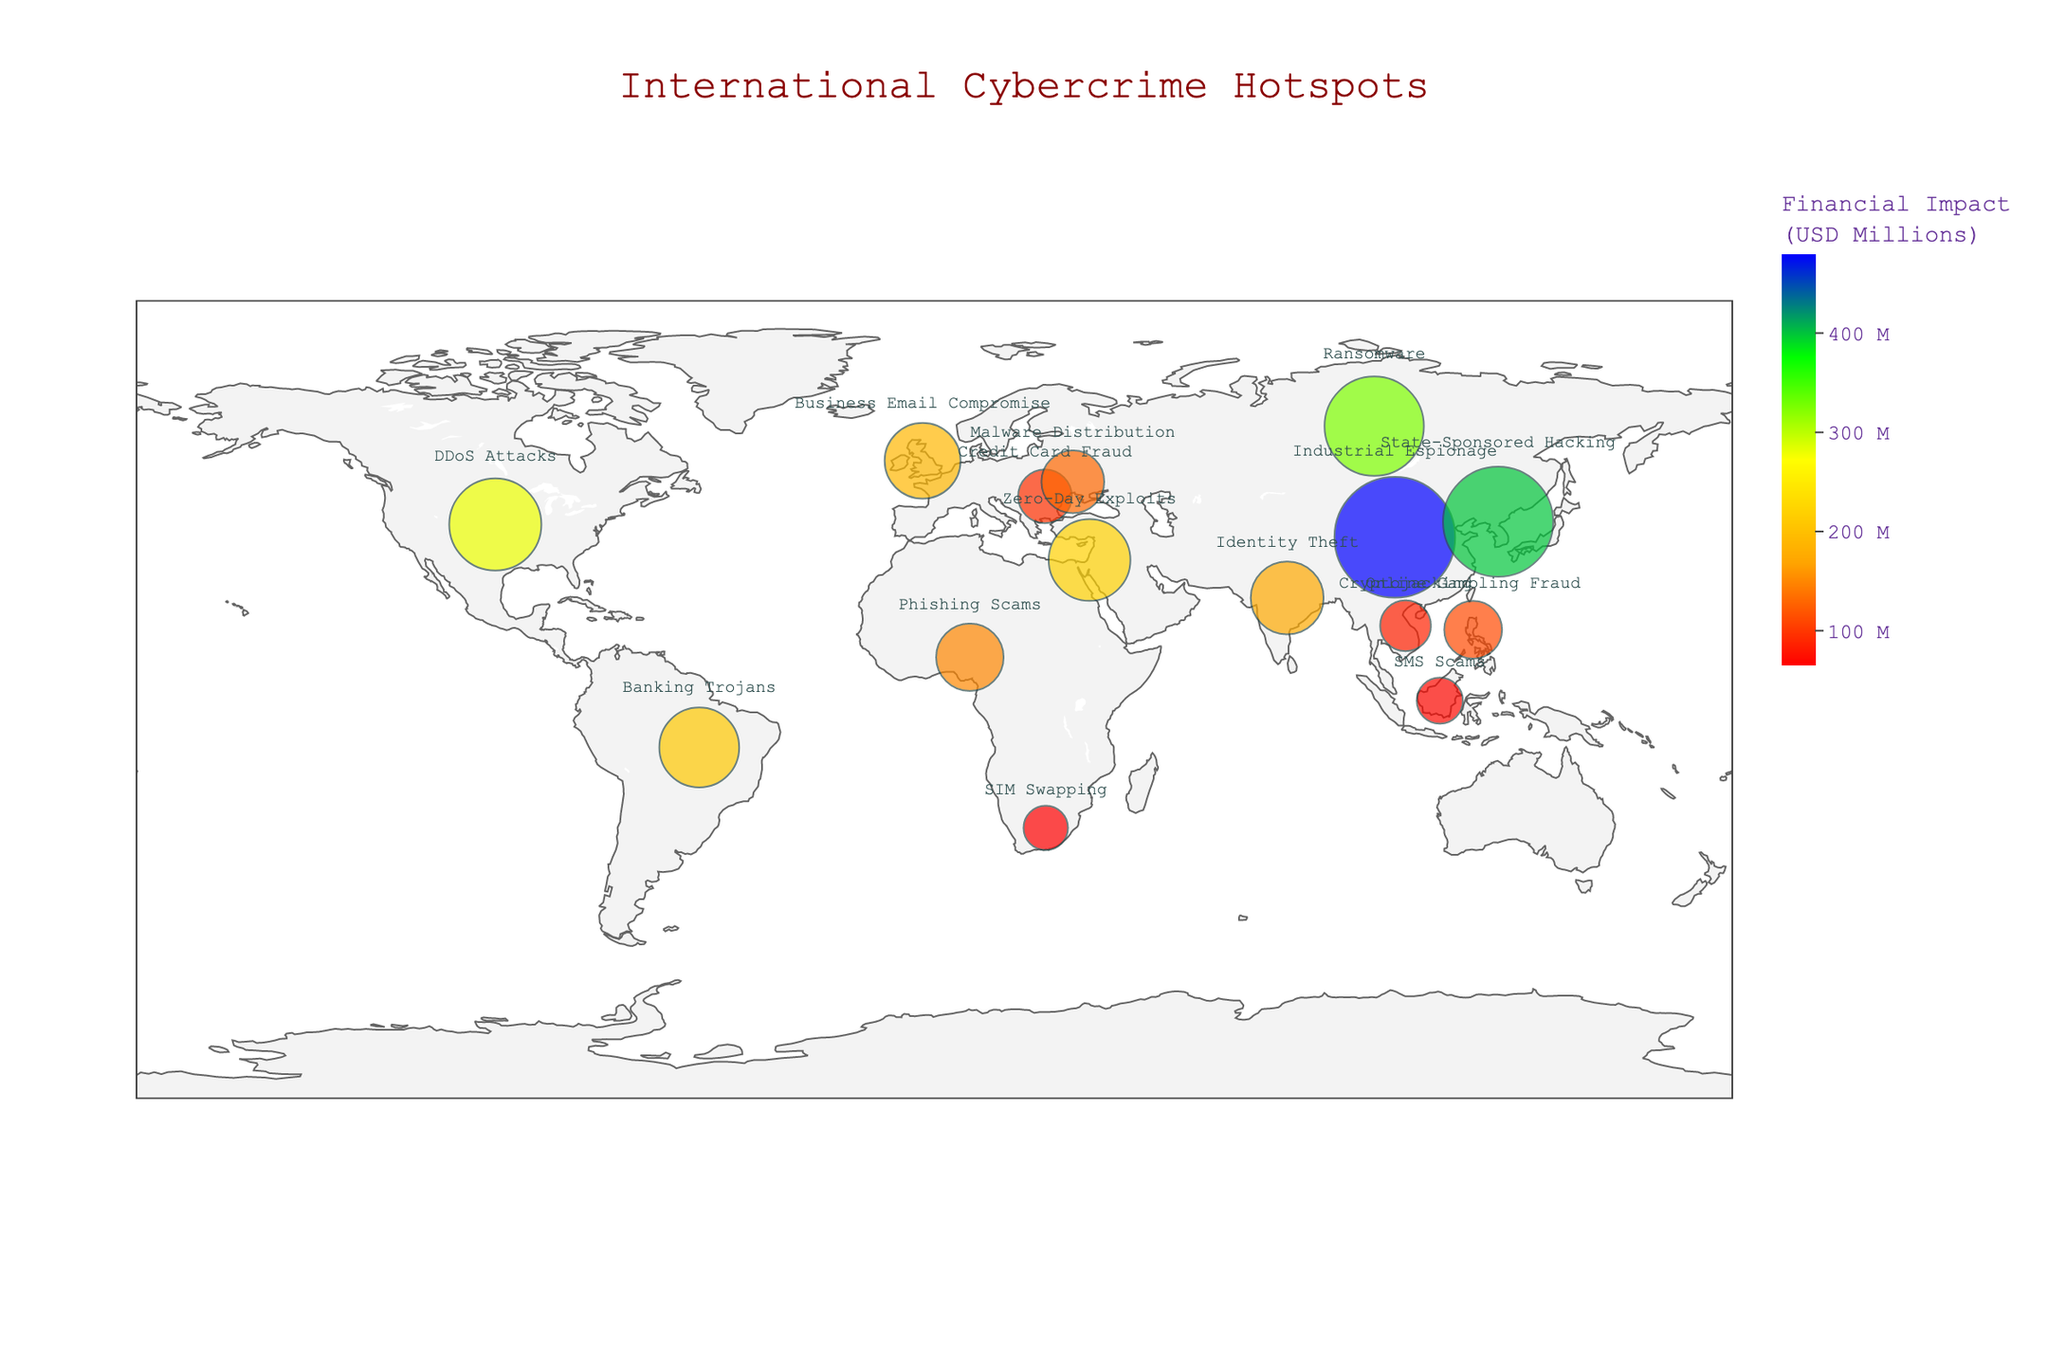How many different cities are represented in the figure? To find the answer, count the distinct cities mentioned in the "City" column. The cities are Moscow, Shanghai, Sao Paulo, Lagos, Bucharest, New York, Mumbai, Kyiv, Ho Chi Minh City, Pyongyang, Jakarta, Tel Aviv, London, Manila, and Johannesburg.
Answer: 15 Which city has the highest financial impact of cybercrime? Look at the size of the points and the value beside each point. The largest circle, indicating the highest financial impact, corresponds to Shanghai in China with $480 million.
Answer: Shanghai What is the total financial impact across all cities in the figure? Sum up the financial impacts for each city: 325 + 480 + 210 + 150 + 95 + 280 + 175 + 130 + 85 + 400 + 70 + 220 + 190 + 110 + 65 = 2985 million USD.
Answer: 2985 Which city and attack type combination is associated with the lowest financial impact? Look for the smallest circle on the map and check the hover text for the attached city and attack type. The smallest circle represents Jakarta with SMS Scams, amounting to $70 million.
Answer: Jakarta, SMS Scams How does the financial impact of cybercrime in New York compare to that in London? Identify the financial impacts for both New York and London from the figure. New York has $280 million and London has $190 million. Comparing the two, New York has a higher financial impact.
Answer: New York has a higher financial impact What is the average financial impact of cybercrimes across all cities? First, sum up all the financial impacts, which total 2985 million USD. Then, divide this by the number of cities (15). The average financial impact is 2985 / 15 ≈ 199 million USD.
Answer: ~199 Which attack type has the third highest financial impact? Sort the cities based on financial impact in descending order: Shanghai (Industrial Espionage - 480), Pyongyang (State-Sponsored Hacking - 400), Moscow (Ransomware - 325). So, the third highest is Ransomware.
Answer: Ransomware What color represents the city with the lowest financial impact? Locate the city with the smallest circle (Jakarta). The color associated with Jakarta can be mapped onto the lower end of the custom color scale, denoted by a red hue.
Answer: Red Between Ho Chi Minh City and Tel Aviv, which city has a higher financial impact and by how much? Look at the financial impacts of both cities. Ho Chi Minh City has $85 million and Tel Aviv has $220 million. The difference is 220 - 85 = 135 million USD.
Answer: Tel Aviv by 135 million USD What are the common types of cyberattacks occurring in Asian cities? Identify the cities located in Asia and their respective attack types: Shanghai (Industrial Espionage), Mumbai (Identity Theft), Ho Chi Minh City (Cryptojacking), Pyongyang (State-Sponsored Hacking), Jakarta (SMS Scams).
Answer: Industrial Espionage, Identity Theft, Cryptojacking, State-Sponsored Hacking, SMS Scams 